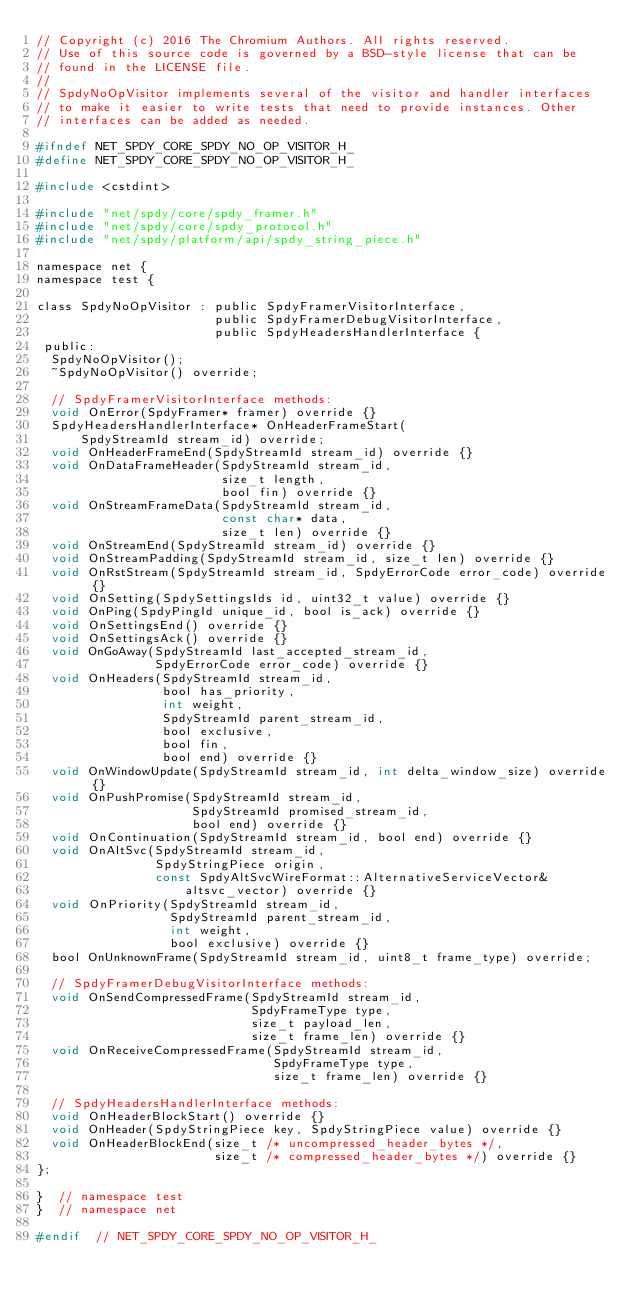Convert code to text. <code><loc_0><loc_0><loc_500><loc_500><_C_>// Copyright (c) 2016 The Chromium Authors. All rights reserved.
// Use of this source code is governed by a BSD-style license that can be
// found in the LICENSE file.
//
// SpdyNoOpVisitor implements several of the visitor and handler interfaces
// to make it easier to write tests that need to provide instances. Other
// interfaces can be added as needed.

#ifndef NET_SPDY_CORE_SPDY_NO_OP_VISITOR_H_
#define NET_SPDY_CORE_SPDY_NO_OP_VISITOR_H_

#include <cstdint>

#include "net/spdy/core/spdy_framer.h"
#include "net/spdy/core/spdy_protocol.h"
#include "net/spdy/platform/api/spdy_string_piece.h"

namespace net {
namespace test {

class SpdyNoOpVisitor : public SpdyFramerVisitorInterface,
                        public SpdyFramerDebugVisitorInterface,
                        public SpdyHeadersHandlerInterface {
 public:
  SpdyNoOpVisitor();
  ~SpdyNoOpVisitor() override;

  // SpdyFramerVisitorInterface methods:
  void OnError(SpdyFramer* framer) override {}
  SpdyHeadersHandlerInterface* OnHeaderFrameStart(
      SpdyStreamId stream_id) override;
  void OnHeaderFrameEnd(SpdyStreamId stream_id) override {}
  void OnDataFrameHeader(SpdyStreamId stream_id,
                         size_t length,
                         bool fin) override {}
  void OnStreamFrameData(SpdyStreamId stream_id,
                         const char* data,
                         size_t len) override {}
  void OnStreamEnd(SpdyStreamId stream_id) override {}
  void OnStreamPadding(SpdyStreamId stream_id, size_t len) override {}
  void OnRstStream(SpdyStreamId stream_id, SpdyErrorCode error_code) override {}
  void OnSetting(SpdySettingsIds id, uint32_t value) override {}
  void OnPing(SpdyPingId unique_id, bool is_ack) override {}
  void OnSettingsEnd() override {}
  void OnSettingsAck() override {}
  void OnGoAway(SpdyStreamId last_accepted_stream_id,
                SpdyErrorCode error_code) override {}
  void OnHeaders(SpdyStreamId stream_id,
                 bool has_priority,
                 int weight,
                 SpdyStreamId parent_stream_id,
                 bool exclusive,
                 bool fin,
                 bool end) override {}
  void OnWindowUpdate(SpdyStreamId stream_id, int delta_window_size) override {}
  void OnPushPromise(SpdyStreamId stream_id,
                     SpdyStreamId promised_stream_id,
                     bool end) override {}
  void OnContinuation(SpdyStreamId stream_id, bool end) override {}
  void OnAltSvc(SpdyStreamId stream_id,
                SpdyStringPiece origin,
                const SpdyAltSvcWireFormat::AlternativeServiceVector&
                    altsvc_vector) override {}
  void OnPriority(SpdyStreamId stream_id,
                  SpdyStreamId parent_stream_id,
                  int weight,
                  bool exclusive) override {}
  bool OnUnknownFrame(SpdyStreamId stream_id, uint8_t frame_type) override;

  // SpdyFramerDebugVisitorInterface methods:
  void OnSendCompressedFrame(SpdyStreamId stream_id,
                             SpdyFrameType type,
                             size_t payload_len,
                             size_t frame_len) override {}
  void OnReceiveCompressedFrame(SpdyStreamId stream_id,
                                SpdyFrameType type,
                                size_t frame_len) override {}

  // SpdyHeadersHandlerInterface methods:
  void OnHeaderBlockStart() override {}
  void OnHeader(SpdyStringPiece key, SpdyStringPiece value) override {}
  void OnHeaderBlockEnd(size_t /* uncompressed_header_bytes */,
                        size_t /* compressed_header_bytes */) override {}
};

}  // namespace test
}  // namespace net

#endif  // NET_SPDY_CORE_SPDY_NO_OP_VISITOR_H_
</code> 